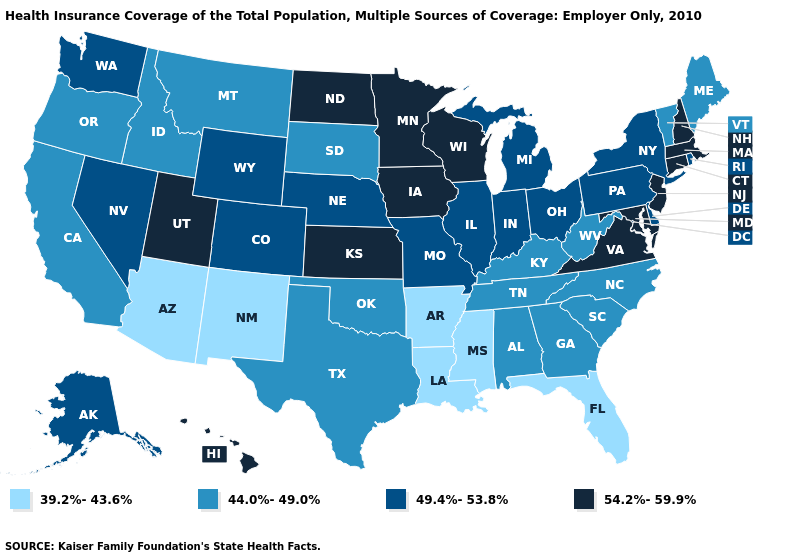Does North Dakota have the highest value in the USA?
Keep it brief. Yes. What is the highest value in the USA?
Quick response, please. 54.2%-59.9%. Among the states that border Louisiana , does Texas have the lowest value?
Concise answer only. No. What is the value of Indiana?
Be succinct. 49.4%-53.8%. Name the states that have a value in the range 49.4%-53.8%?
Give a very brief answer. Alaska, Colorado, Delaware, Illinois, Indiana, Michigan, Missouri, Nebraska, Nevada, New York, Ohio, Pennsylvania, Rhode Island, Washington, Wyoming. Name the states that have a value in the range 44.0%-49.0%?
Write a very short answer. Alabama, California, Georgia, Idaho, Kentucky, Maine, Montana, North Carolina, Oklahoma, Oregon, South Carolina, South Dakota, Tennessee, Texas, Vermont, West Virginia. Does the first symbol in the legend represent the smallest category?
Short answer required. Yes. What is the highest value in the West ?
Give a very brief answer. 54.2%-59.9%. Name the states that have a value in the range 39.2%-43.6%?
Short answer required. Arizona, Arkansas, Florida, Louisiana, Mississippi, New Mexico. Among the states that border Michigan , does Ohio have the lowest value?
Short answer required. Yes. Which states have the lowest value in the USA?
Be succinct. Arizona, Arkansas, Florida, Louisiana, Mississippi, New Mexico. Name the states that have a value in the range 49.4%-53.8%?
Write a very short answer. Alaska, Colorado, Delaware, Illinois, Indiana, Michigan, Missouri, Nebraska, Nevada, New York, Ohio, Pennsylvania, Rhode Island, Washington, Wyoming. What is the value of Oregon?
Short answer required. 44.0%-49.0%. Among the states that border Mississippi , which have the lowest value?
Write a very short answer. Arkansas, Louisiana. Name the states that have a value in the range 49.4%-53.8%?
Answer briefly. Alaska, Colorado, Delaware, Illinois, Indiana, Michigan, Missouri, Nebraska, Nevada, New York, Ohio, Pennsylvania, Rhode Island, Washington, Wyoming. 